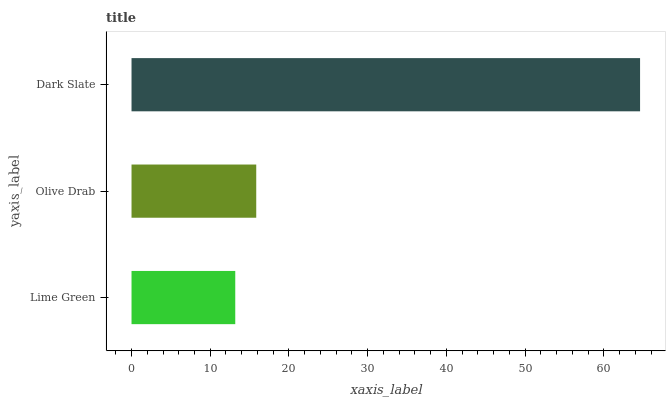Is Lime Green the minimum?
Answer yes or no. Yes. Is Dark Slate the maximum?
Answer yes or no. Yes. Is Olive Drab the minimum?
Answer yes or no. No. Is Olive Drab the maximum?
Answer yes or no. No. Is Olive Drab greater than Lime Green?
Answer yes or no. Yes. Is Lime Green less than Olive Drab?
Answer yes or no. Yes. Is Lime Green greater than Olive Drab?
Answer yes or no. No. Is Olive Drab less than Lime Green?
Answer yes or no. No. Is Olive Drab the high median?
Answer yes or no. Yes. Is Olive Drab the low median?
Answer yes or no. Yes. Is Lime Green the high median?
Answer yes or no. No. Is Lime Green the low median?
Answer yes or no. No. 